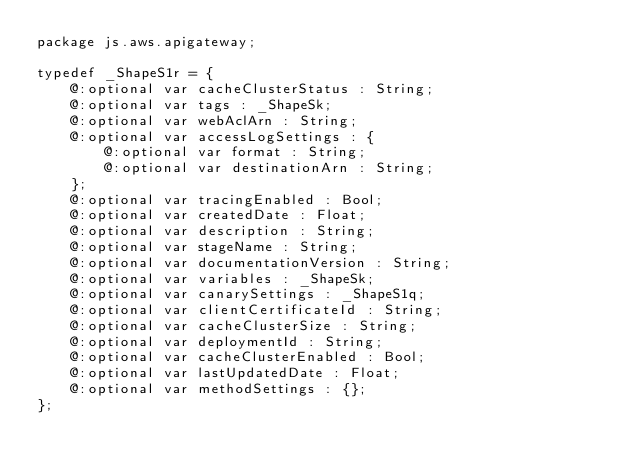<code> <loc_0><loc_0><loc_500><loc_500><_Haxe_>package js.aws.apigateway;

typedef _ShapeS1r = {
    @:optional var cacheClusterStatus : String;
    @:optional var tags : _ShapeSk;
    @:optional var webAclArn : String;
    @:optional var accessLogSettings : {
        @:optional var format : String;
        @:optional var destinationArn : String;
    };
    @:optional var tracingEnabled : Bool;
    @:optional var createdDate : Float;
    @:optional var description : String;
    @:optional var stageName : String;
    @:optional var documentationVersion : String;
    @:optional var variables : _ShapeSk;
    @:optional var canarySettings : _ShapeS1q;
    @:optional var clientCertificateId : String;
    @:optional var cacheClusterSize : String;
    @:optional var deploymentId : String;
    @:optional var cacheClusterEnabled : Bool;
    @:optional var lastUpdatedDate : Float;
    @:optional var methodSettings : {};
};
</code> 